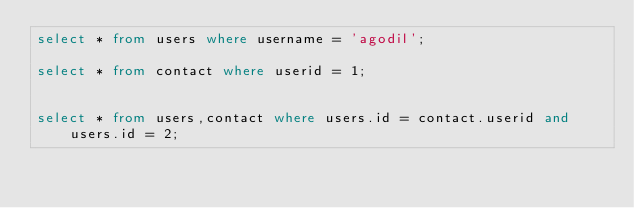Convert code to text. <code><loc_0><loc_0><loc_500><loc_500><_SQL_>select * from users where username = 'agodil';

select * from contact where userid = 1;


select * from users,contact where users.id = contact.userid and users.id = 2;
</code> 